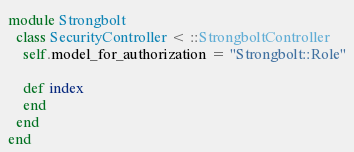Convert code to text. <code><loc_0><loc_0><loc_500><loc_500><_Ruby_>module Strongbolt
  class SecurityController < ::StrongboltController
    self.model_for_authorization = "Strongbolt::Role"

    def index
    end
  end
end
</code> 